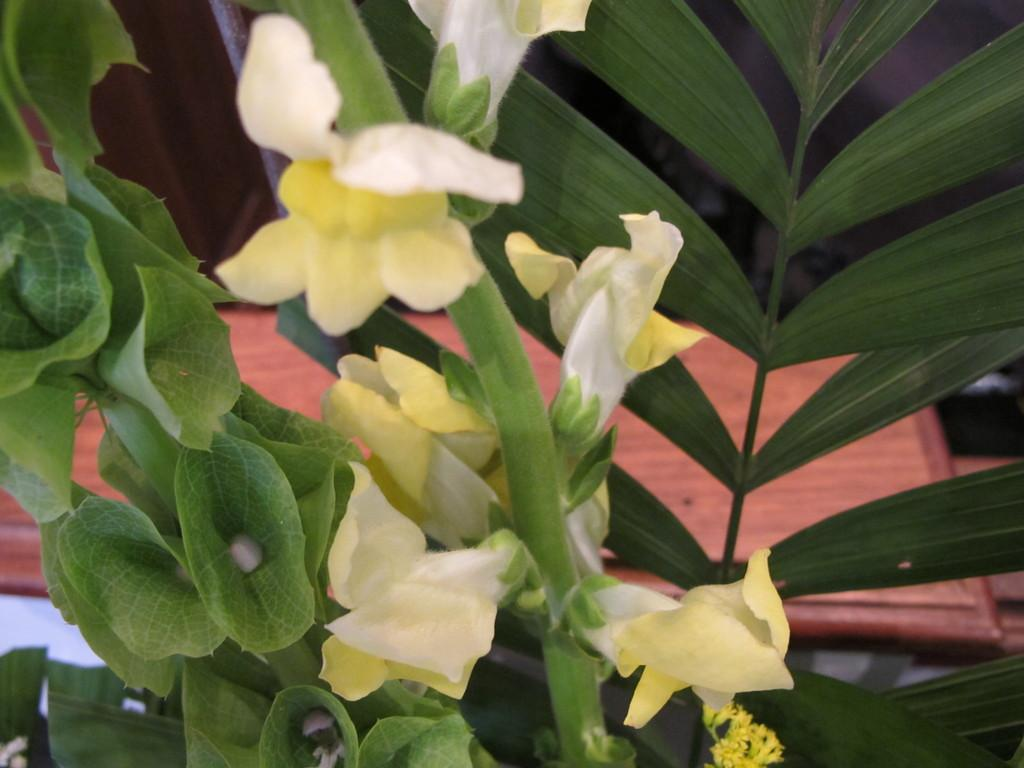What type of plants can be seen in the image? There are flowers and green leaves in the image. Can you describe the color of the flowers? The provided facts do not mention the color of the flowers, so we cannot definitively answer that question. What is the color of the leaves in the image? The leaves in the image are green. What type of prose is being recited by the flowers in the image? There are no people or voices present in the image, and the flowers are not reciting any prose. Can you tell me how many zippers are visible on the flowers in the image? There are no zippers present on the flowers in the image. 